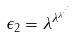Convert formula to latex. <formula><loc_0><loc_0><loc_500><loc_500>\epsilon _ { 2 } = \lambda ^ { \lambda ^ { \lambda ^ { \cdot ^ { \cdot ^ { \cdot } } } } }</formula> 